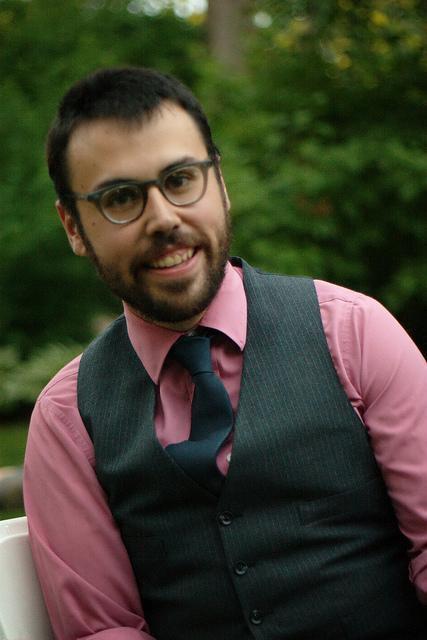How many men are there?
Give a very brief answer. 1. How many zebras are there?
Give a very brief answer. 0. 